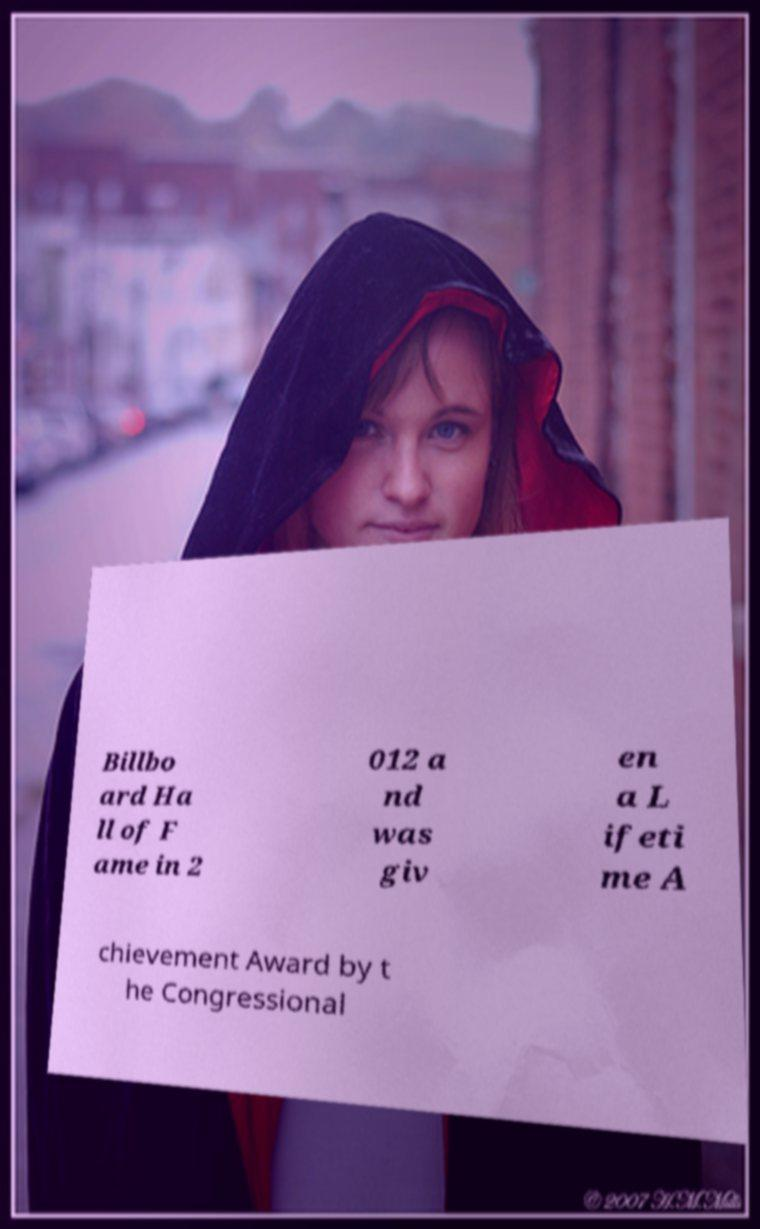Please identify and transcribe the text found in this image. Billbo ard Ha ll of F ame in 2 012 a nd was giv en a L ifeti me A chievement Award by t he Congressional 